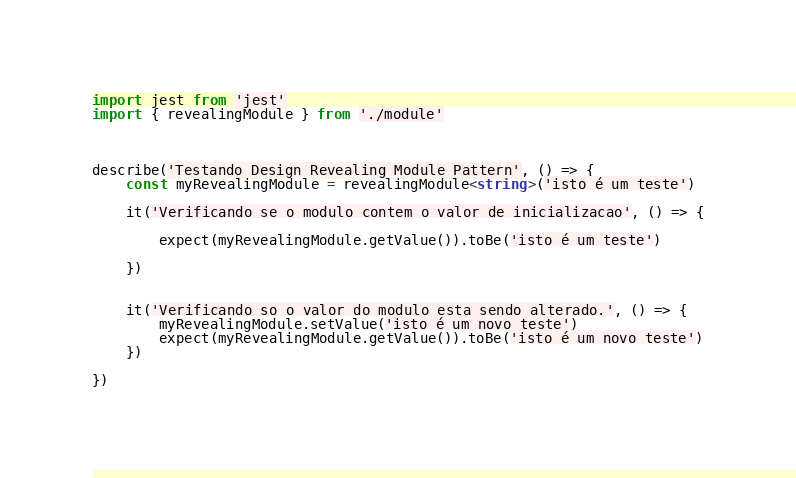Convert code to text. <code><loc_0><loc_0><loc_500><loc_500><_TypeScript_>import jest from 'jest'
import { revealingModule } from './module'



describe('Testando Design Revealing Module Pattern', () => {
    const myRevealingModule = revealingModule<string>('isto é um teste')

    it('Verificando se o modulo contem o valor de inicializacao', () => {

        expect(myRevealingModule.getValue()).toBe('isto é um teste')

    })


    it('Verificando so o valor do modulo esta sendo alterado.', () => {
        myRevealingModule.setValue('isto é um novo teste')
        expect(myRevealingModule.getValue()).toBe('isto é um novo teste')
    })

})</code> 